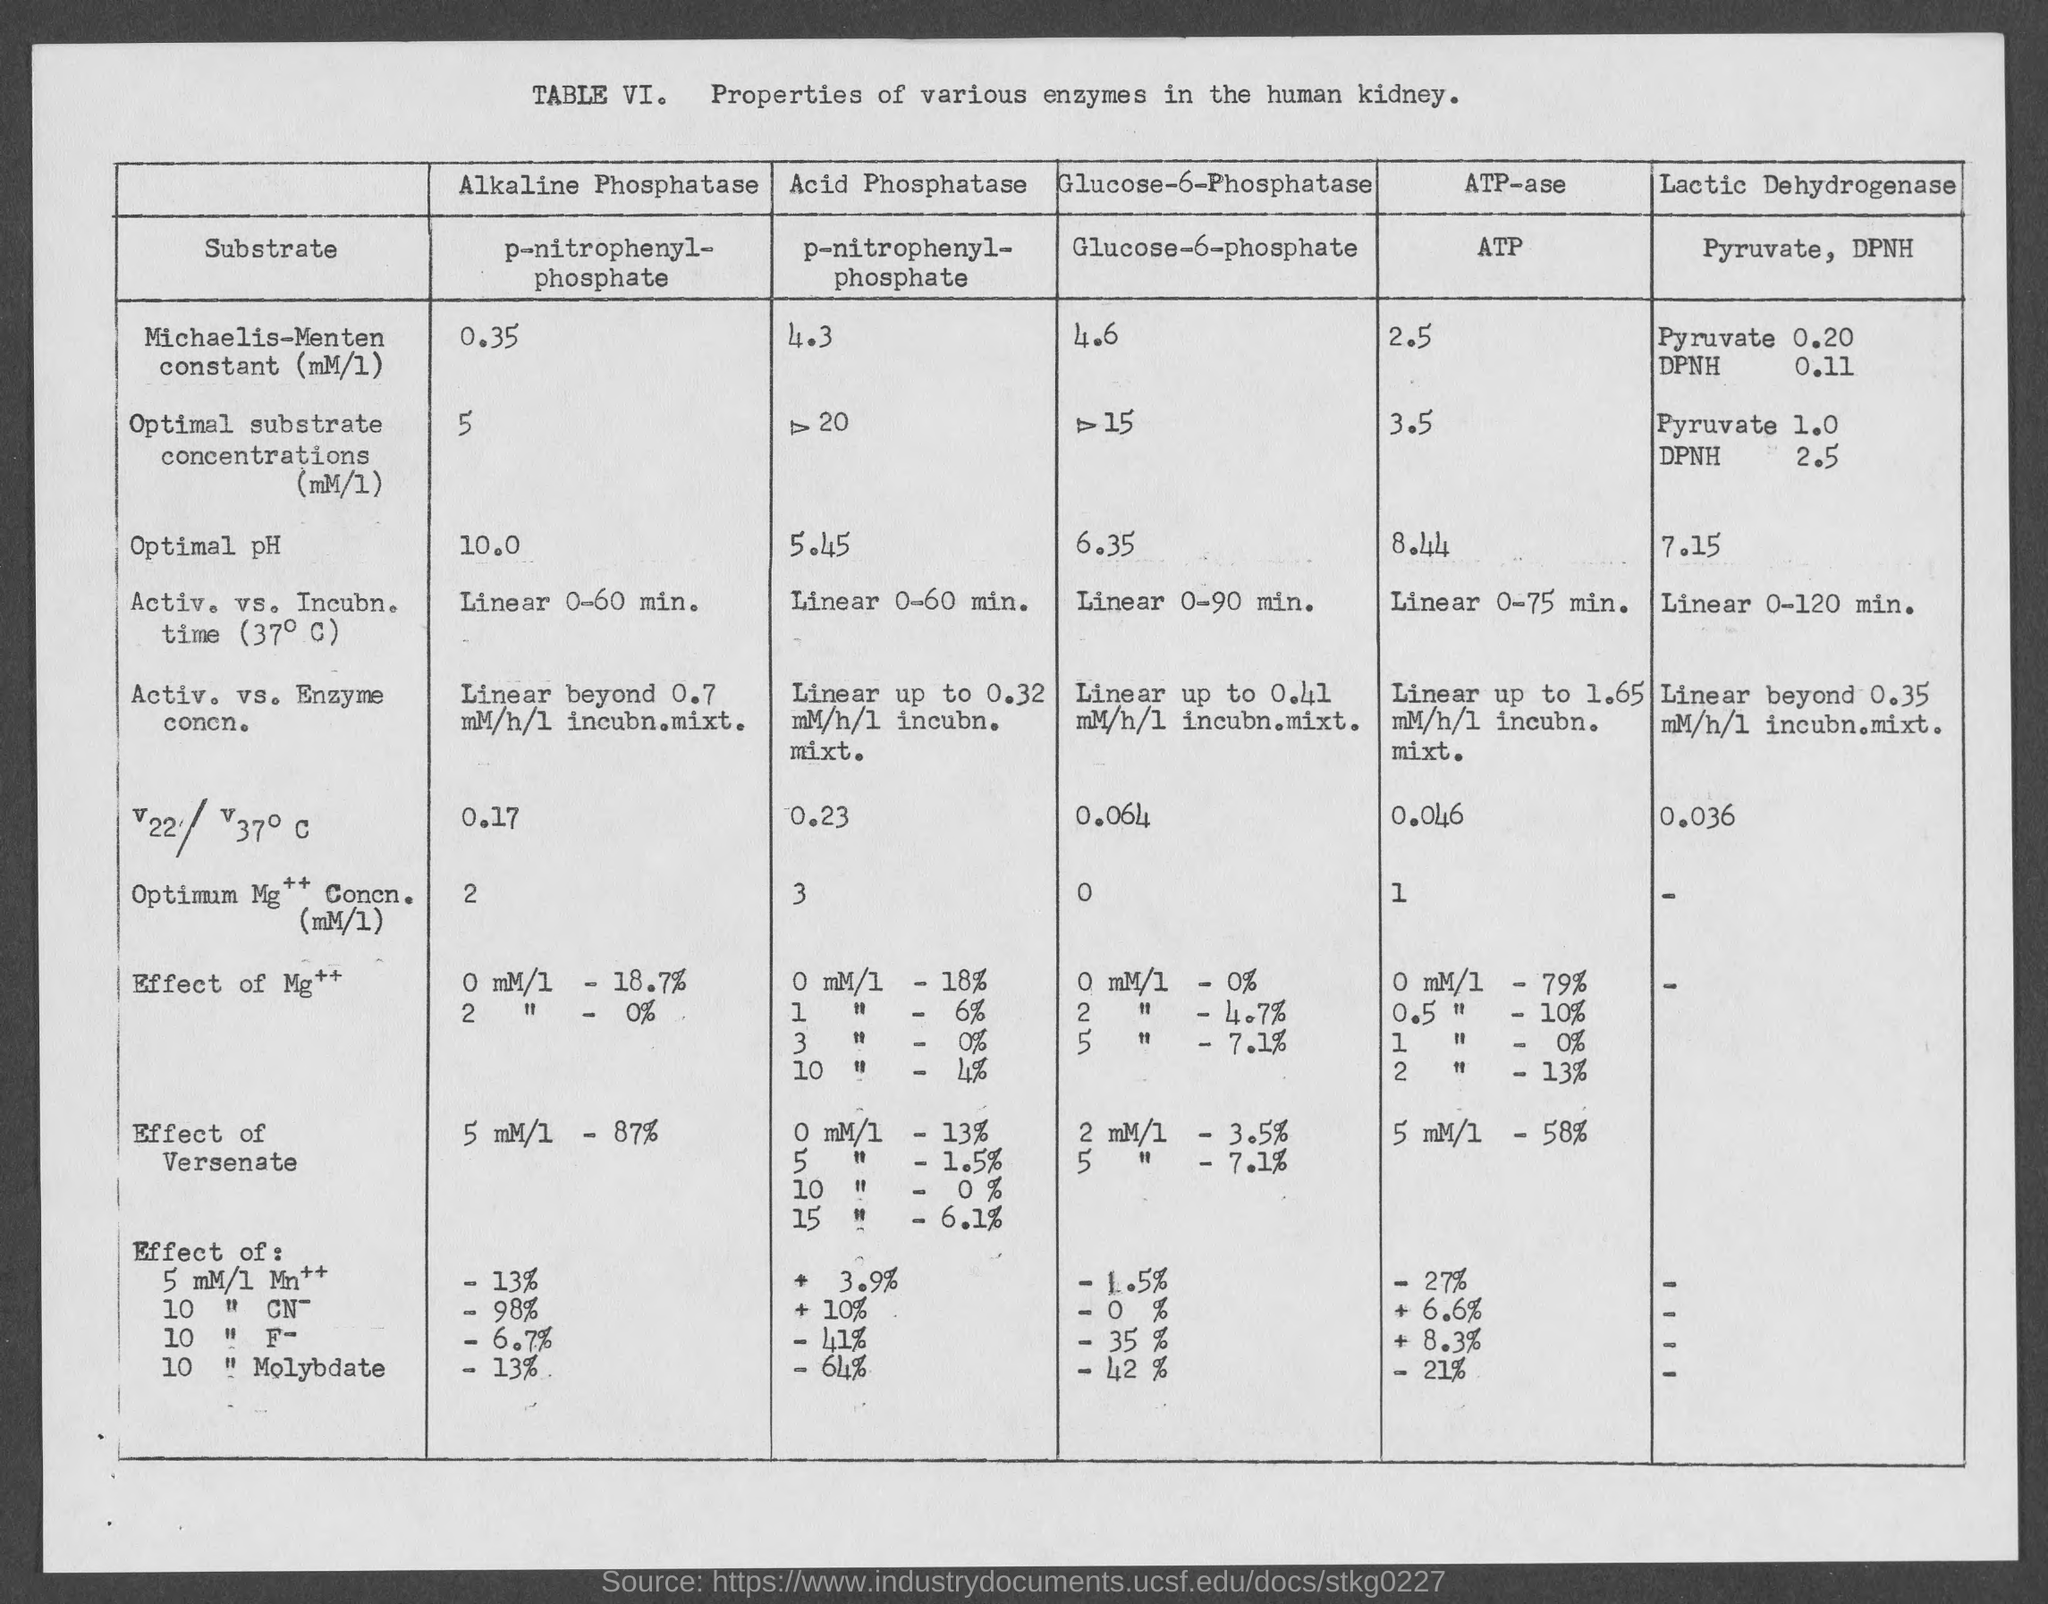What is the table no.?
Offer a terse response. VI. 